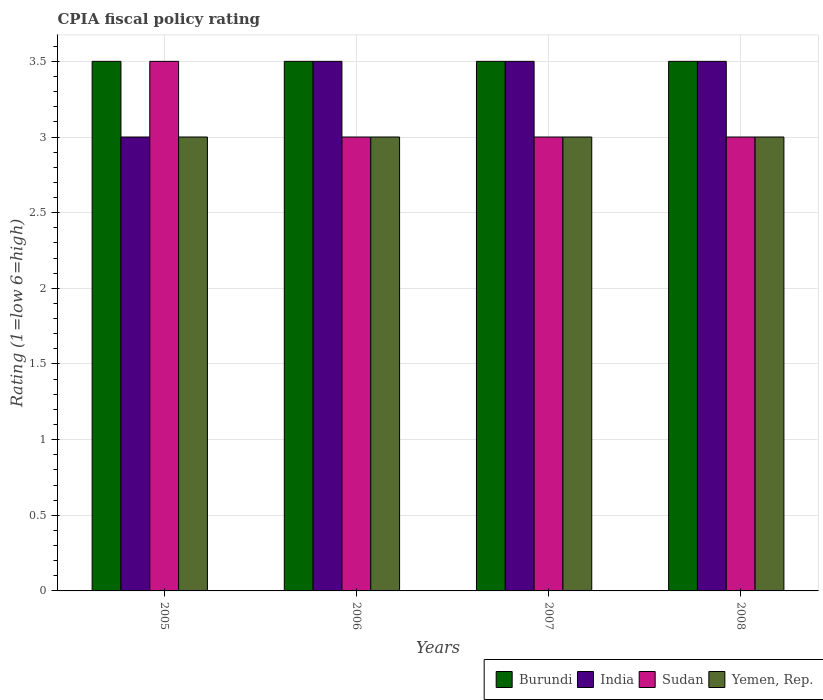Are the number of bars per tick equal to the number of legend labels?
Your answer should be compact. Yes. Are the number of bars on each tick of the X-axis equal?
Provide a succinct answer. Yes. How many bars are there on the 2nd tick from the left?
Provide a succinct answer. 4. What is the label of the 3rd group of bars from the left?
Make the answer very short. 2007. In which year was the CPIA rating in Sudan minimum?
Keep it short and to the point. 2006. What is the difference between the CPIA rating in India in 2007 and the CPIA rating in Burundi in 2006?
Offer a terse response. 0. What is the average CPIA rating in Burundi per year?
Ensure brevity in your answer.  3.5. What is the difference between the highest and the lowest CPIA rating in Burundi?
Make the answer very short. 0. In how many years, is the CPIA rating in Yemen, Rep. greater than the average CPIA rating in Yemen, Rep. taken over all years?
Your response must be concise. 0. What does the 1st bar from the left in 2007 represents?
Provide a short and direct response. Burundi. What does the 3rd bar from the right in 2008 represents?
Your response must be concise. India. Is it the case that in every year, the sum of the CPIA rating in Burundi and CPIA rating in India is greater than the CPIA rating in Yemen, Rep.?
Provide a succinct answer. Yes. How many years are there in the graph?
Provide a succinct answer. 4. Does the graph contain grids?
Ensure brevity in your answer.  Yes. How many legend labels are there?
Keep it short and to the point. 4. What is the title of the graph?
Give a very brief answer. CPIA fiscal policy rating. What is the label or title of the Y-axis?
Offer a very short reply. Rating (1=low 6=high). What is the Rating (1=low 6=high) in Burundi in 2005?
Keep it short and to the point. 3.5. What is the Rating (1=low 6=high) in India in 2005?
Your answer should be very brief. 3. What is the Rating (1=low 6=high) of Sudan in 2005?
Keep it short and to the point. 3.5. What is the Rating (1=low 6=high) of Burundi in 2006?
Your answer should be compact. 3.5. What is the Rating (1=low 6=high) of India in 2006?
Give a very brief answer. 3.5. What is the Rating (1=low 6=high) of Sudan in 2006?
Your response must be concise. 3. What is the Rating (1=low 6=high) of Burundi in 2007?
Offer a terse response. 3.5. What is the Rating (1=low 6=high) of Yemen, Rep. in 2007?
Your response must be concise. 3. What is the Rating (1=low 6=high) in Burundi in 2008?
Provide a short and direct response. 3.5. What is the Rating (1=low 6=high) of Sudan in 2008?
Provide a short and direct response. 3. Across all years, what is the maximum Rating (1=low 6=high) in Burundi?
Your answer should be compact. 3.5. Across all years, what is the maximum Rating (1=low 6=high) of India?
Make the answer very short. 3.5. Across all years, what is the minimum Rating (1=low 6=high) in Burundi?
Your answer should be very brief. 3.5. Across all years, what is the minimum Rating (1=low 6=high) in Sudan?
Keep it short and to the point. 3. What is the total Rating (1=low 6=high) in India in the graph?
Your answer should be very brief. 13.5. What is the total Rating (1=low 6=high) of Sudan in the graph?
Make the answer very short. 12.5. What is the difference between the Rating (1=low 6=high) of Burundi in 2005 and that in 2006?
Make the answer very short. 0. What is the difference between the Rating (1=low 6=high) of Sudan in 2005 and that in 2006?
Your answer should be very brief. 0.5. What is the difference between the Rating (1=low 6=high) in Burundi in 2005 and that in 2007?
Offer a very short reply. 0. What is the difference between the Rating (1=low 6=high) in Sudan in 2005 and that in 2007?
Your answer should be very brief. 0.5. What is the difference between the Rating (1=low 6=high) in Yemen, Rep. in 2005 and that in 2007?
Ensure brevity in your answer.  0. What is the difference between the Rating (1=low 6=high) in Burundi in 2005 and that in 2008?
Keep it short and to the point. 0. What is the difference between the Rating (1=low 6=high) in Sudan in 2005 and that in 2008?
Give a very brief answer. 0.5. What is the difference between the Rating (1=low 6=high) of Yemen, Rep. in 2005 and that in 2008?
Make the answer very short. 0. What is the difference between the Rating (1=low 6=high) of Sudan in 2006 and that in 2007?
Your answer should be very brief. 0. What is the difference between the Rating (1=low 6=high) in Burundi in 2006 and that in 2008?
Keep it short and to the point. 0. What is the difference between the Rating (1=low 6=high) in India in 2006 and that in 2008?
Provide a succinct answer. 0. What is the difference between the Rating (1=low 6=high) of India in 2007 and that in 2008?
Ensure brevity in your answer.  0. What is the difference between the Rating (1=low 6=high) of Sudan in 2007 and that in 2008?
Offer a very short reply. 0. What is the difference between the Rating (1=low 6=high) in Burundi in 2005 and the Rating (1=low 6=high) in India in 2006?
Make the answer very short. 0. What is the difference between the Rating (1=low 6=high) in Burundi in 2005 and the Rating (1=low 6=high) in Sudan in 2006?
Your answer should be compact. 0.5. What is the difference between the Rating (1=low 6=high) in India in 2005 and the Rating (1=low 6=high) in Sudan in 2006?
Offer a very short reply. 0. What is the difference between the Rating (1=low 6=high) of Sudan in 2005 and the Rating (1=low 6=high) of Yemen, Rep. in 2006?
Provide a succinct answer. 0.5. What is the difference between the Rating (1=low 6=high) of Burundi in 2005 and the Rating (1=low 6=high) of India in 2007?
Your answer should be compact. 0. What is the difference between the Rating (1=low 6=high) of Burundi in 2005 and the Rating (1=low 6=high) of Sudan in 2007?
Offer a very short reply. 0.5. What is the difference between the Rating (1=low 6=high) in Burundi in 2005 and the Rating (1=low 6=high) in Yemen, Rep. in 2007?
Ensure brevity in your answer.  0.5. What is the difference between the Rating (1=low 6=high) of India in 2005 and the Rating (1=low 6=high) of Yemen, Rep. in 2007?
Provide a succinct answer. 0. What is the difference between the Rating (1=low 6=high) in Burundi in 2005 and the Rating (1=low 6=high) in Sudan in 2008?
Ensure brevity in your answer.  0.5. What is the difference between the Rating (1=low 6=high) in Burundi in 2005 and the Rating (1=low 6=high) in Yemen, Rep. in 2008?
Give a very brief answer. 0.5. What is the difference between the Rating (1=low 6=high) in India in 2005 and the Rating (1=low 6=high) in Yemen, Rep. in 2008?
Give a very brief answer. 0. What is the difference between the Rating (1=low 6=high) of Sudan in 2005 and the Rating (1=low 6=high) of Yemen, Rep. in 2008?
Provide a succinct answer. 0.5. What is the difference between the Rating (1=low 6=high) of Burundi in 2006 and the Rating (1=low 6=high) of Sudan in 2007?
Keep it short and to the point. 0.5. What is the difference between the Rating (1=low 6=high) of India in 2006 and the Rating (1=low 6=high) of Sudan in 2007?
Your answer should be compact. 0.5. What is the difference between the Rating (1=low 6=high) in Sudan in 2006 and the Rating (1=low 6=high) in Yemen, Rep. in 2007?
Give a very brief answer. 0. What is the difference between the Rating (1=low 6=high) in Burundi in 2006 and the Rating (1=low 6=high) in India in 2008?
Your answer should be compact. 0. What is the difference between the Rating (1=low 6=high) of Burundi in 2006 and the Rating (1=low 6=high) of Yemen, Rep. in 2008?
Offer a very short reply. 0.5. What is the difference between the Rating (1=low 6=high) in India in 2006 and the Rating (1=low 6=high) in Yemen, Rep. in 2008?
Offer a terse response. 0.5. What is the difference between the Rating (1=low 6=high) of Sudan in 2006 and the Rating (1=low 6=high) of Yemen, Rep. in 2008?
Provide a succinct answer. 0. What is the difference between the Rating (1=low 6=high) of Burundi in 2007 and the Rating (1=low 6=high) of India in 2008?
Offer a terse response. 0. What is the difference between the Rating (1=low 6=high) in Burundi in 2007 and the Rating (1=low 6=high) in Sudan in 2008?
Offer a very short reply. 0.5. What is the difference between the Rating (1=low 6=high) of India in 2007 and the Rating (1=low 6=high) of Sudan in 2008?
Your response must be concise. 0.5. What is the difference between the Rating (1=low 6=high) in Sudan in 2007 and the Rating (1=low 6=high) in Yemen, Rep. in 2008?
Offer a very short reply. 0. What is the average Rating (1=low 6=high) in Burundi per year?
Provide a succinct answer. 3.5. What is the average Rating (1=low 6=high) of India per year?
Make the answer very short. 3.38. What is the average Rating (1=low 6=high) of Sudan per year?
Make the answer very short. 3.12. In the year 2005, what is the difference between the Rating (1=low 6=high) of Burundi and Rating (1=low 6=high) of Yemen, Rep.?
Give a very brief answer. 0.5. In the year 2005, what is the difference between the Rating (1=low 6=high) of India and Rating (1=low 6=high) of Sudan?
Your response must be concise. -0.5. In the year 2005, what is the difference between the Rating (1=low 6=high) in India and Rating (1=low 6=high) in Yemen, Rep.?
Your answer should be compact. 0. In the year 2006, what is the difference between the Rating (1=low 6=high) in Burundi and Rating (1=low 6=high) in Sudan?
Give a very brief answer. 0.5. In the year 2006, what is the difference between the Rating (1=low 6=high) in India and Rating (1=low 6=high) in Sudan?
Give a very brief answer. 0.5. In the year 2007, what is the difference between the Rating (1=low 6=high) in India and Rating (1=low 6=high) in Yemen, Rep.?
Ensure brevity in your answer.  0.5. In the year 2007, what is the difference between the Rating (1=low 6=high) of Sudan and Rating (1=low 6=high) of Yemen, Rep.?
Keep it short and to the point. 0. In the year 2008, what is the difference between the Rating (1=low 6=high) of Burundi and Rating (1=low 6=high) of India?
Provide a short and direct response. 0. In the year 2008, what is the difference between the Rating (1=low 6=high) in India and Rating (1=low 6=high) in Yemen, Rep.?
Give a very brief answer. 0.5. In the year 2008, what is the difference between the Rating (1=low 6=high) in Sudan and Rating (1=low 6=high) in Yemen, Rep.?
Make the answer very short. 0. What is the ratio of the Rating (1=low 6=high) in Burundi in 2005 to that in 2006?
Give a very brief answer. 1. What is the ratio of the Rating (1=low 6=high) of Sudan in 2005 to that in 2007?
Your answer should be compact. 1.17. What is the ratio of the Rating (1=low 6=high) of Yemen, Rep. in 2005 to that in 2007?
Your response must be concise. 1. What is the ratio of the Rating (1=low 6=high) in Burundi in 2005 to that in 2008?
Give a very brief answer. 1. What is the ratio of the Rating (1=low 6=high) of Yemen, Rep. in 2005 to that in 2008?
Your answer should be compact. 1. What is the ratio of the Rating (1=low 6=high) in Burundi in 2006 to that in 2007?
Offer a terse response. 1. What is the ratio of the Rating (1=low 6=high) in India in 2006 to that in 2007?
Offer a terse response. 1. What is the ratio of the Rating (1=low 6=high) in Sudan in 2006 to that in 2007?
Offer a very short reply. 1. What is the ratio of the Rating (1=low 6=high) in India in 2006 to that in 2008?
Your answer should be compact. 1. What is the ratio of the Rating (1=low 6=high) in India in 2007 to that in 2008?
Make the answer very short. 1. What is the ratio of the Rating (1=low 6=high) in Sudan in 2007 to that in 2008?
Offer a terse response. 1. What is the difference between the highest and the second highest Rating (1=low 6=high) in Burundi?
Provide a succinct answer. 0. What is the difference between the highest and the second highest Rating (1=low 6=high) in India?
Provide a short and direct response. 0. What is the difference between the highest and the second highest Rating (1=low 6=high) in Sudan?
Provide a short and direct response. 0.5. What is the difference between the highest and the lowest Rating (1=low 6=high) of Burundi?
Your response must be concise. 0. What is the difference between the highest and the lowest Rating (1=low 6=high) of India?
Keep it short and to the point. 0.5. What is the difference between the highest and the lowest Rating (1=low 6=high) of Sudan?
Provide a short and direct response. 0.5. 